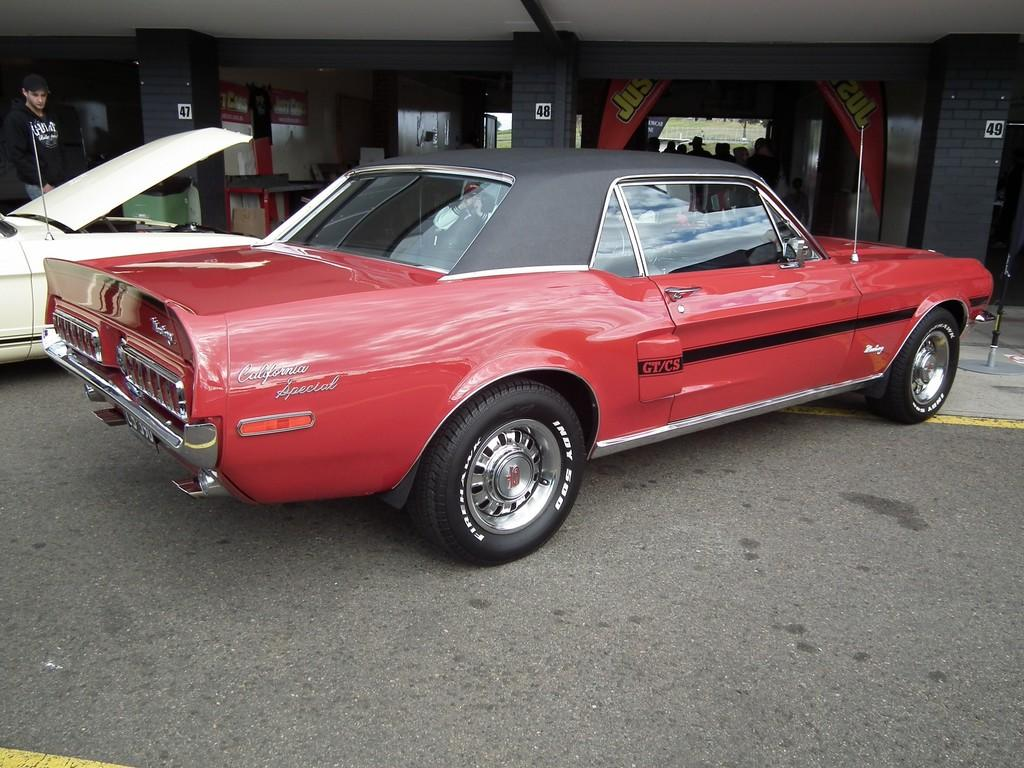What can be seen in front of the building in the image? There are cars in front of the building in the image. Can you describe the person in the image? There is a person in the top left of the image, and they are wearing clothes. How many sheep can be seen in the yard in the image? There are no sheep or yards present in the image; it features cars in front of a building and a person in the top left corner. 